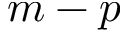<formula> <loc_0><loc_0><loc_500><loc_500>m - p</formula> 